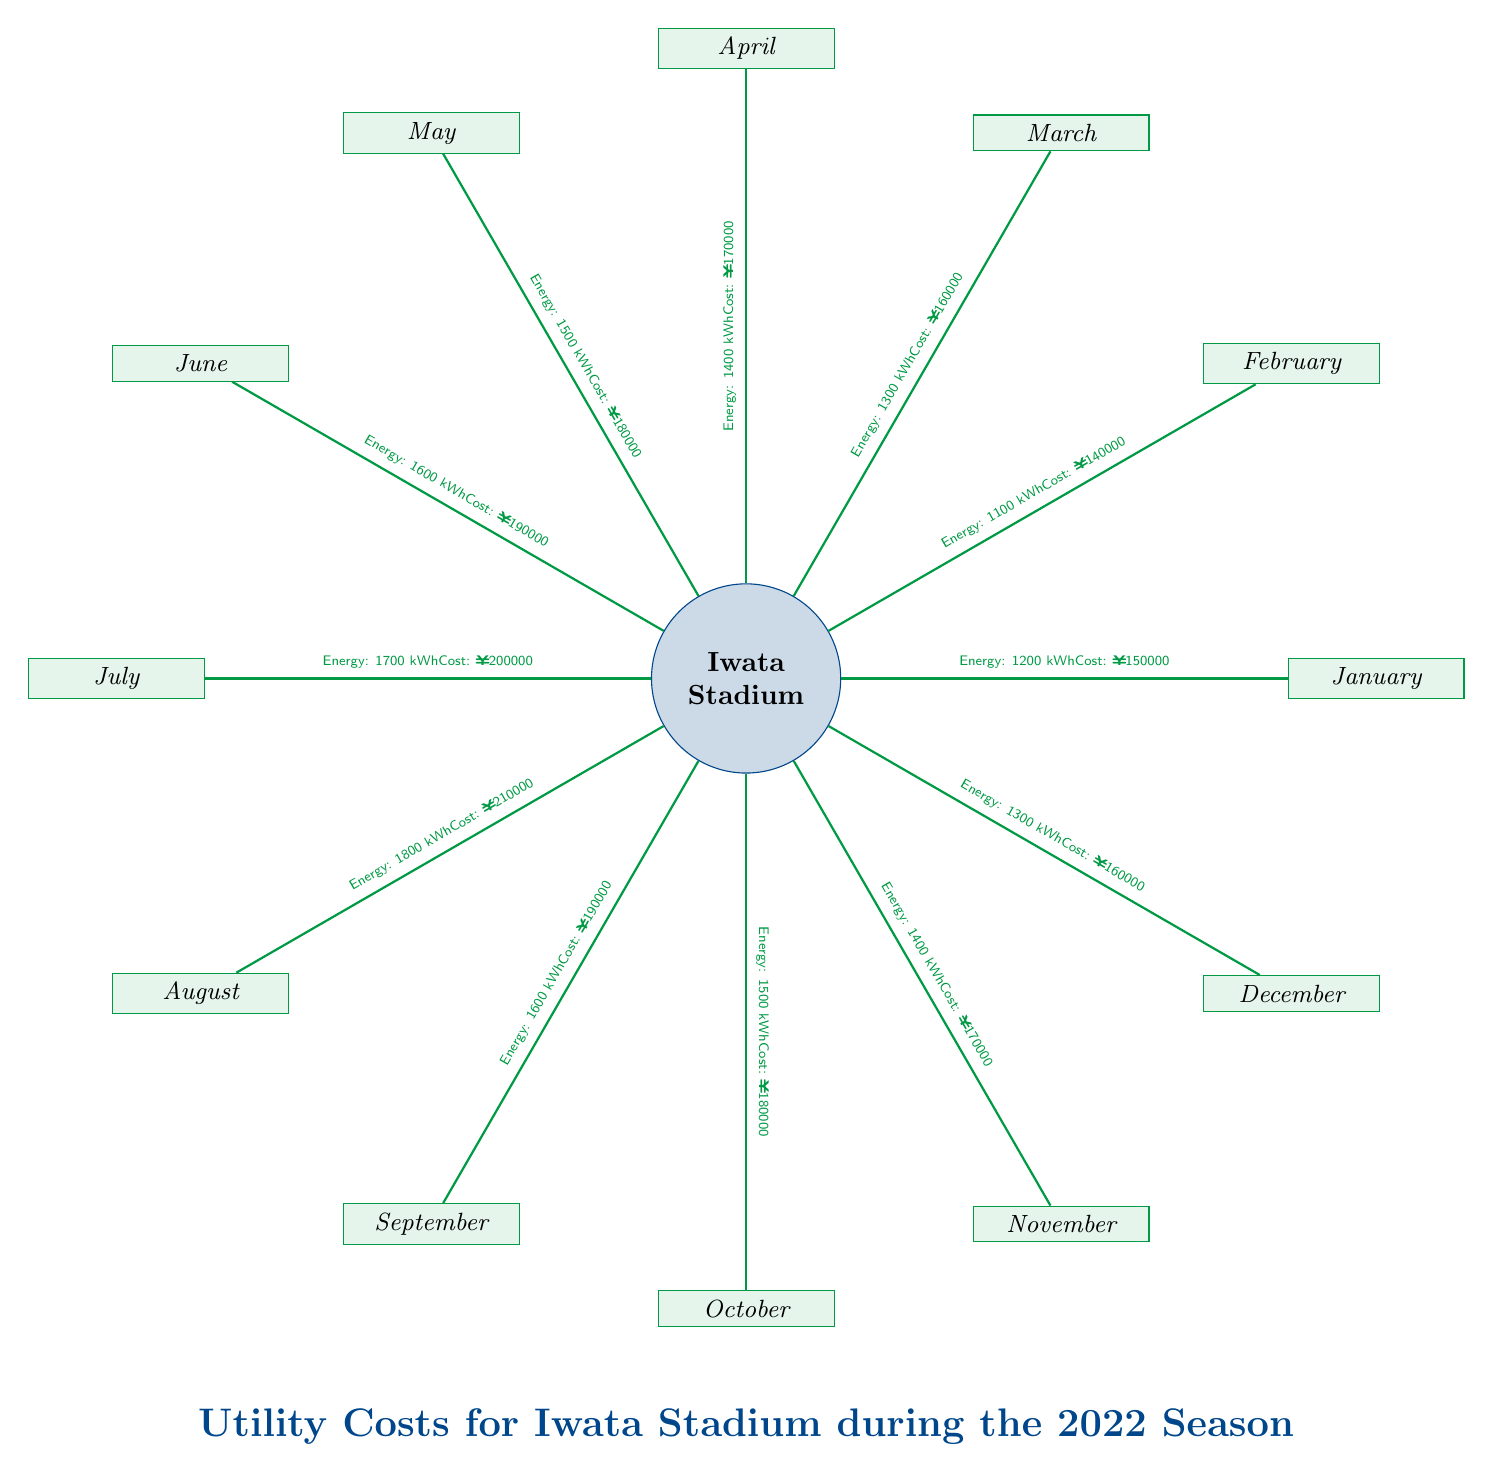What is the energy consumption in December? The diagram specifies that the energy consumption for December is listed as 1300 kWh. Therefore, the direct answer can be extracted from the node for December.
Answer: 1300 kWh What is the total utility cost for Iwata Stadium in January? By examining the data related to January, the cost is displayed as ¥150000, making this a straightforward observation from the corresponding node.
Answer: ¥150000 Which month had the highest energy consumption? To find this, we must review each monthly energy value presented in the diagram. August shows the highest energy consumption at 1800 kWh.
Answer: August How does the utility cost in July compare to that in May? First, we find the costs for both months: July has a cost of ¥200000 and May has ¥180000. Since ¥200000 (July) is greater than ¥180000 (May), we conclude that July's cost is higher.
Answer: Higher What is the total energy consumption for the months of June and September combined? We first find the energy values from both months: June is 1600 kWh and September is 1600 kWh. Adding these two values gives 3200 kWh as the total energy consumption for June and September.
Answer: 3200 kWh Which month had the lowest utility cost? Analyzing the utility costs displayed for all months, February has the lowest cost at ¥140000. This involves comparing all the cost values to identify the minimum.
Answer: February What was the total utility cost for the entire season? We can obtain this by summing up all the monthly costs from the diagram: 150000 + 140000 + 160000 + 170000 + 180000 + 190000 + 200000 + 210000 + 190000 + 180000 + 170000 + 160000, resulting in ¥2110000.
Answer: ¥2110000 What is the energy consumption difference between March and April? The energy consumption for March is 1300 kWh and for April, it is 1400 kWh. The difference is calculated as 1400 - 1300, leading to a difference of 100 kWh.
Answer: 100 kWh 